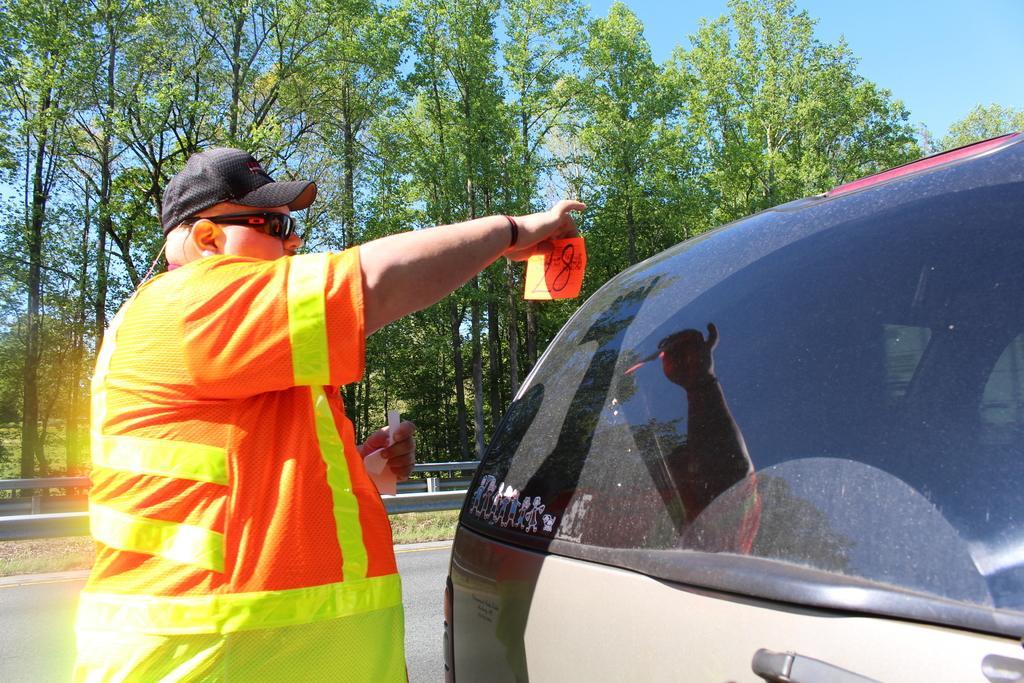Describe this image in one or two sentences. In this image I can see a man is standing. The man is wearing a cap, shades and orange color clothes. Here I can see a vehicle. In the background I can see trees and the sky. 